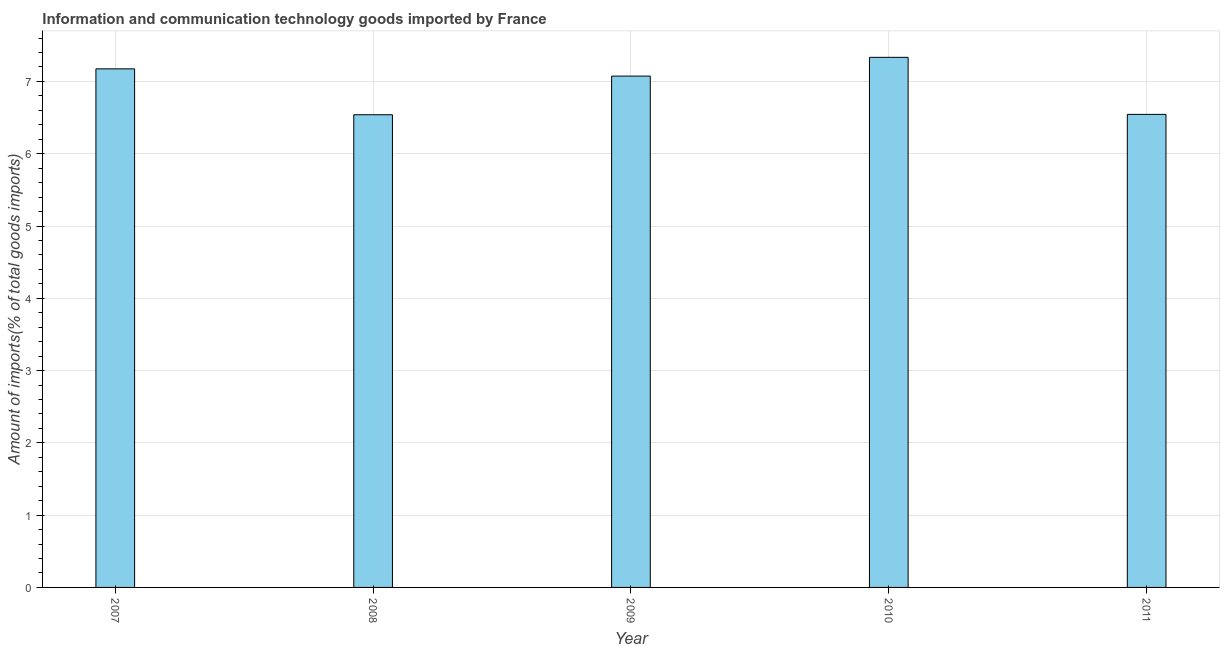Does the graph contain grids?
Provide a succinct answer. Yes. What is the title of the graph?
Keep it short and to the point. Information and communication technology goods imported by France. What is the label or title of the Y-axis?
Your response must be concise. Amount of imports(% of total goods imports). What is the amount of ict goods imports in 2011?
Your response must be concise. 6.54. Across all years, what is the maximum amount of ict goods imports?
Your response must be concise. 7.33. Across all years, what is the minimum amount of ict goods imports?
Make the answer very short. 6.54. In which year was the amount of ict goods imports minimum?
Your answer should be compact. 2008. What is the sum of the amount of ict goods imports?
Keep it short and to the point. 34.66. What is the difference between the amount of ict goods imports in 2007 and 2010?
Provide a short and direct response. -0.16. What is the average amount of ict goods imports per year?
Your answer should be compact. 6.93. What is the median amount of ict goods imports?
Your answer should be compact. 7.07. In how many years, is the amount of ict goods imports greater than 6.6 %?
Offer a very short reply. 3. What is the ratio of the amount of ict goods imports in 2007 to that in 2008?
Offer a terse response. 1.1. Is the difference between the amount of ict goods imports in 2007 and 2009 greater than the difference between any two years?
Your answer should be very brief. No. What is the difference between the highest and the second highest amount of ict goods imports?
Offer a very short reply. 0.16. What is the difference between the highest and the lowest amount of ict goods imports?
Give a very brief answer. 0.79. How many bars are there?
Your answer should be compact. 5. What is the Amount of imports(% of total goods imports) in 2007?
Ensure brevity in your answer.  7.17. What is the Amount of imports(% of total goods imports) of 2008?
Offer a terse response. 6.54. What is the Amount of imports(% of total goods imports) of 2009?
Provide a short and direct response. 7.07. What is the Amount of imports(% of total goods imports) in 2010?
Provide a short and direct response. 7.33. What is the Amount of imports(% of total goods imports) in 2011?
Provide a succinct answer. 6.54. What is the difference between the Amount of imports(% of total goods imports) in 2007 and 2008?
Offer a very short reply. 0.63. What is the difference between the Amount of imports(% of total goods imports) in 2007 and 2009?
Provide a short and direct response. 0.1. What is the difference between the Amount of imports(% of total goods imports) in 2007 and 2010?
Provide a succinct answer. -0.16. What is the difference between the Amount of imports(% of total goods imports) in 2007 and 2011?
Offer a very short reply. 0.63. What is the difference between the Amount of imports(% of total goods imports) in 2008 and 2009?
Provide a short and direct response. -0.53. What is the difference between the Amount of imports(% of total goods imports) in 2008 and 2010?
Provide a short and direct response. -0.79. What is the difference between the Amount of imports(% of total goods imports) in 2008 and 2011?
Give a very brief answer. -0. What is the difference between the Amount of imports(% of total goods imports) in 2009 and 2010?
Keep it short and to the point. -0.26. What is the difference between the Amount of imports(% of total goods imports) in 2009 and 2011?
Your response must be concise. 0.53. What is the difference between the Amount of imports(% of total goods imports) in 2010 and 2011?
Ensure brevity in your answer.  0.79. What is the ratio of the Amount of imports(% of total goods imports) in 2007 to that in 2008?
Ensure brevity in your answer.  1.1. What is the ratio of the Amount of imports(% of total goods imports) in 2007 to that in 2010?
Make the answer very short. 0.98. What is the ratio of the Amount of imports(% of total goods imports) in 2007 to that in 2011?
Provide a short and direct response. 1.1. What is the ratio of the Amount of imports(% of total goods imports) in 2008 to that in 2009?
Provide a short and direct response. 0.92. What is the ratio of the Amount of imports(% of total goods imports) in 2008 to that in 2010?
Make the answer very short. 0.89. What is the ratio of the Amount of imports(% of total goods imports) in 2008 to that in 2011?
Offer a terse response. 1. What is the ratio of the Amount of imports(% of total goods imports) in 2009 to that in 2010?
Keep it short and to the point. 0.96. What is the ratio of the Amount of imports(% of total goods imports) in 2009 to that in 2011?
Your answer should be very brief. 1.08. What is the ratio of the Amount of imports(% of total goods imports) in 2010 to that in 2011?
Make the answer very short. 1.12. 